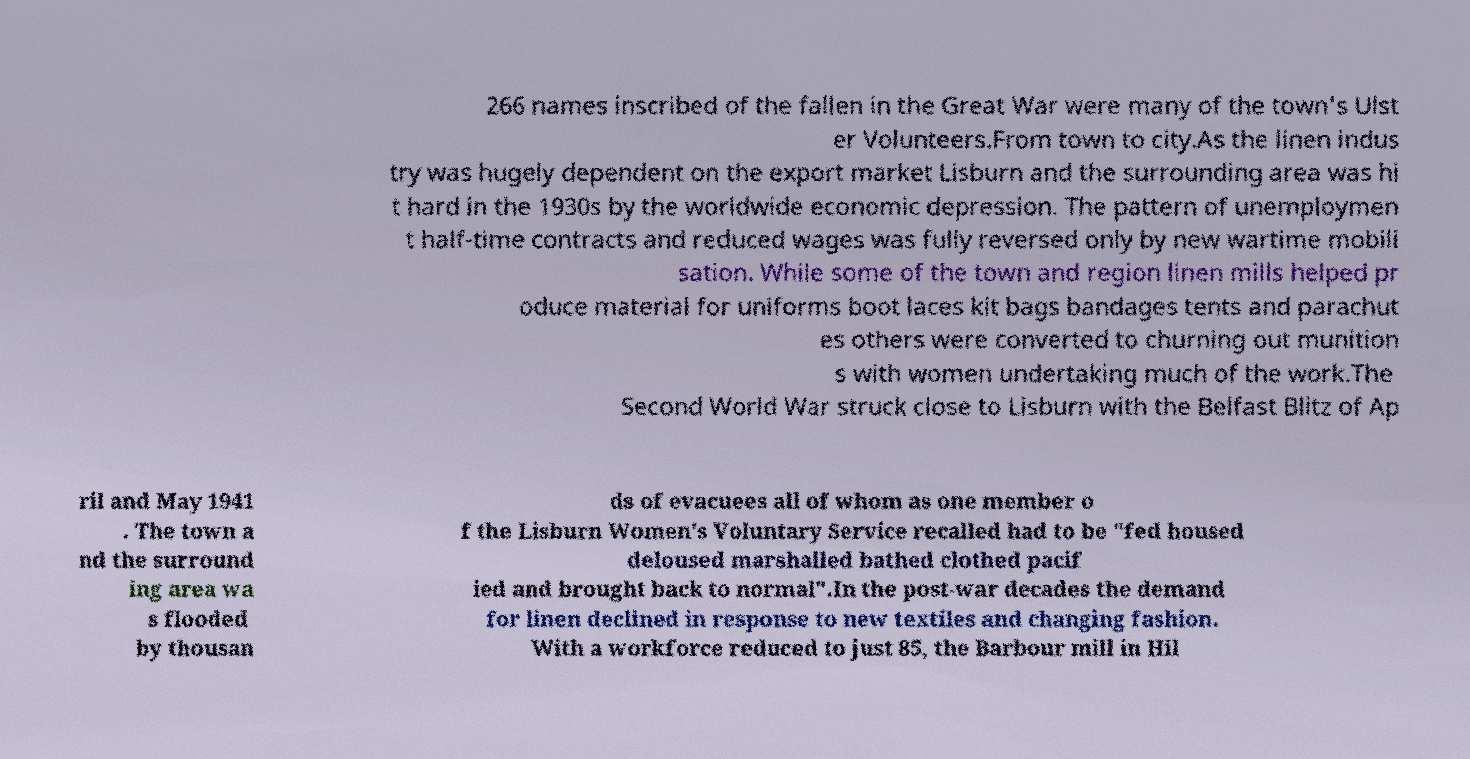There's text embedded in this image that I need extracted. Can you transcribe it verbatim? 266 names inscribed of the fallen in the Great War were many of the town's Ulst er Volunteers.From town to city.As the linen indus try was hugely dependent on the export market Lisburn and the surrounding area was hi t hard in the 1930s by the worldwide economic depression. The pattern of unemploymen t half-time contracts and reduced wages was fully reversed only by new wartime mobili sation. While some of the town and region linen mills helped pr oduce material for uniforms boot laces kit bags bandages tents and parachut es others were converted to churning out munition s with women undertaking much of the work.The Second World War struck close to Lisburn with the Belfast Blitz of Ap ril and May 1941 . The town a nd the surround ing area wa s flooded by thousan ds of evacuees all of whom as one member o f the Lisburn Women's Voluntary Service recalled had to be "fed housed deloused marshalled bathed clothed pacif ied and brought back to normal".In the post-war decades the demand for linen declined in response to new textiles and changing fashion. With a workforce reduced to just 85, the Barbour mill in Hil 